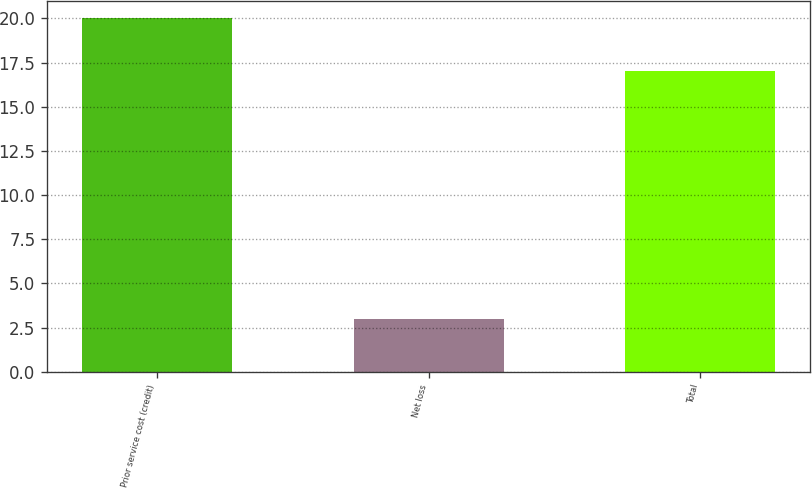Convert chart. <chart><loc_0><loc_0><loc_500><loc_500><bar_chart><fcel>Prior service cost (credit)<fcel>Net loss<fcel>Total<nl><fcel>20<fcel>3<fcel>17<nl></chart> 